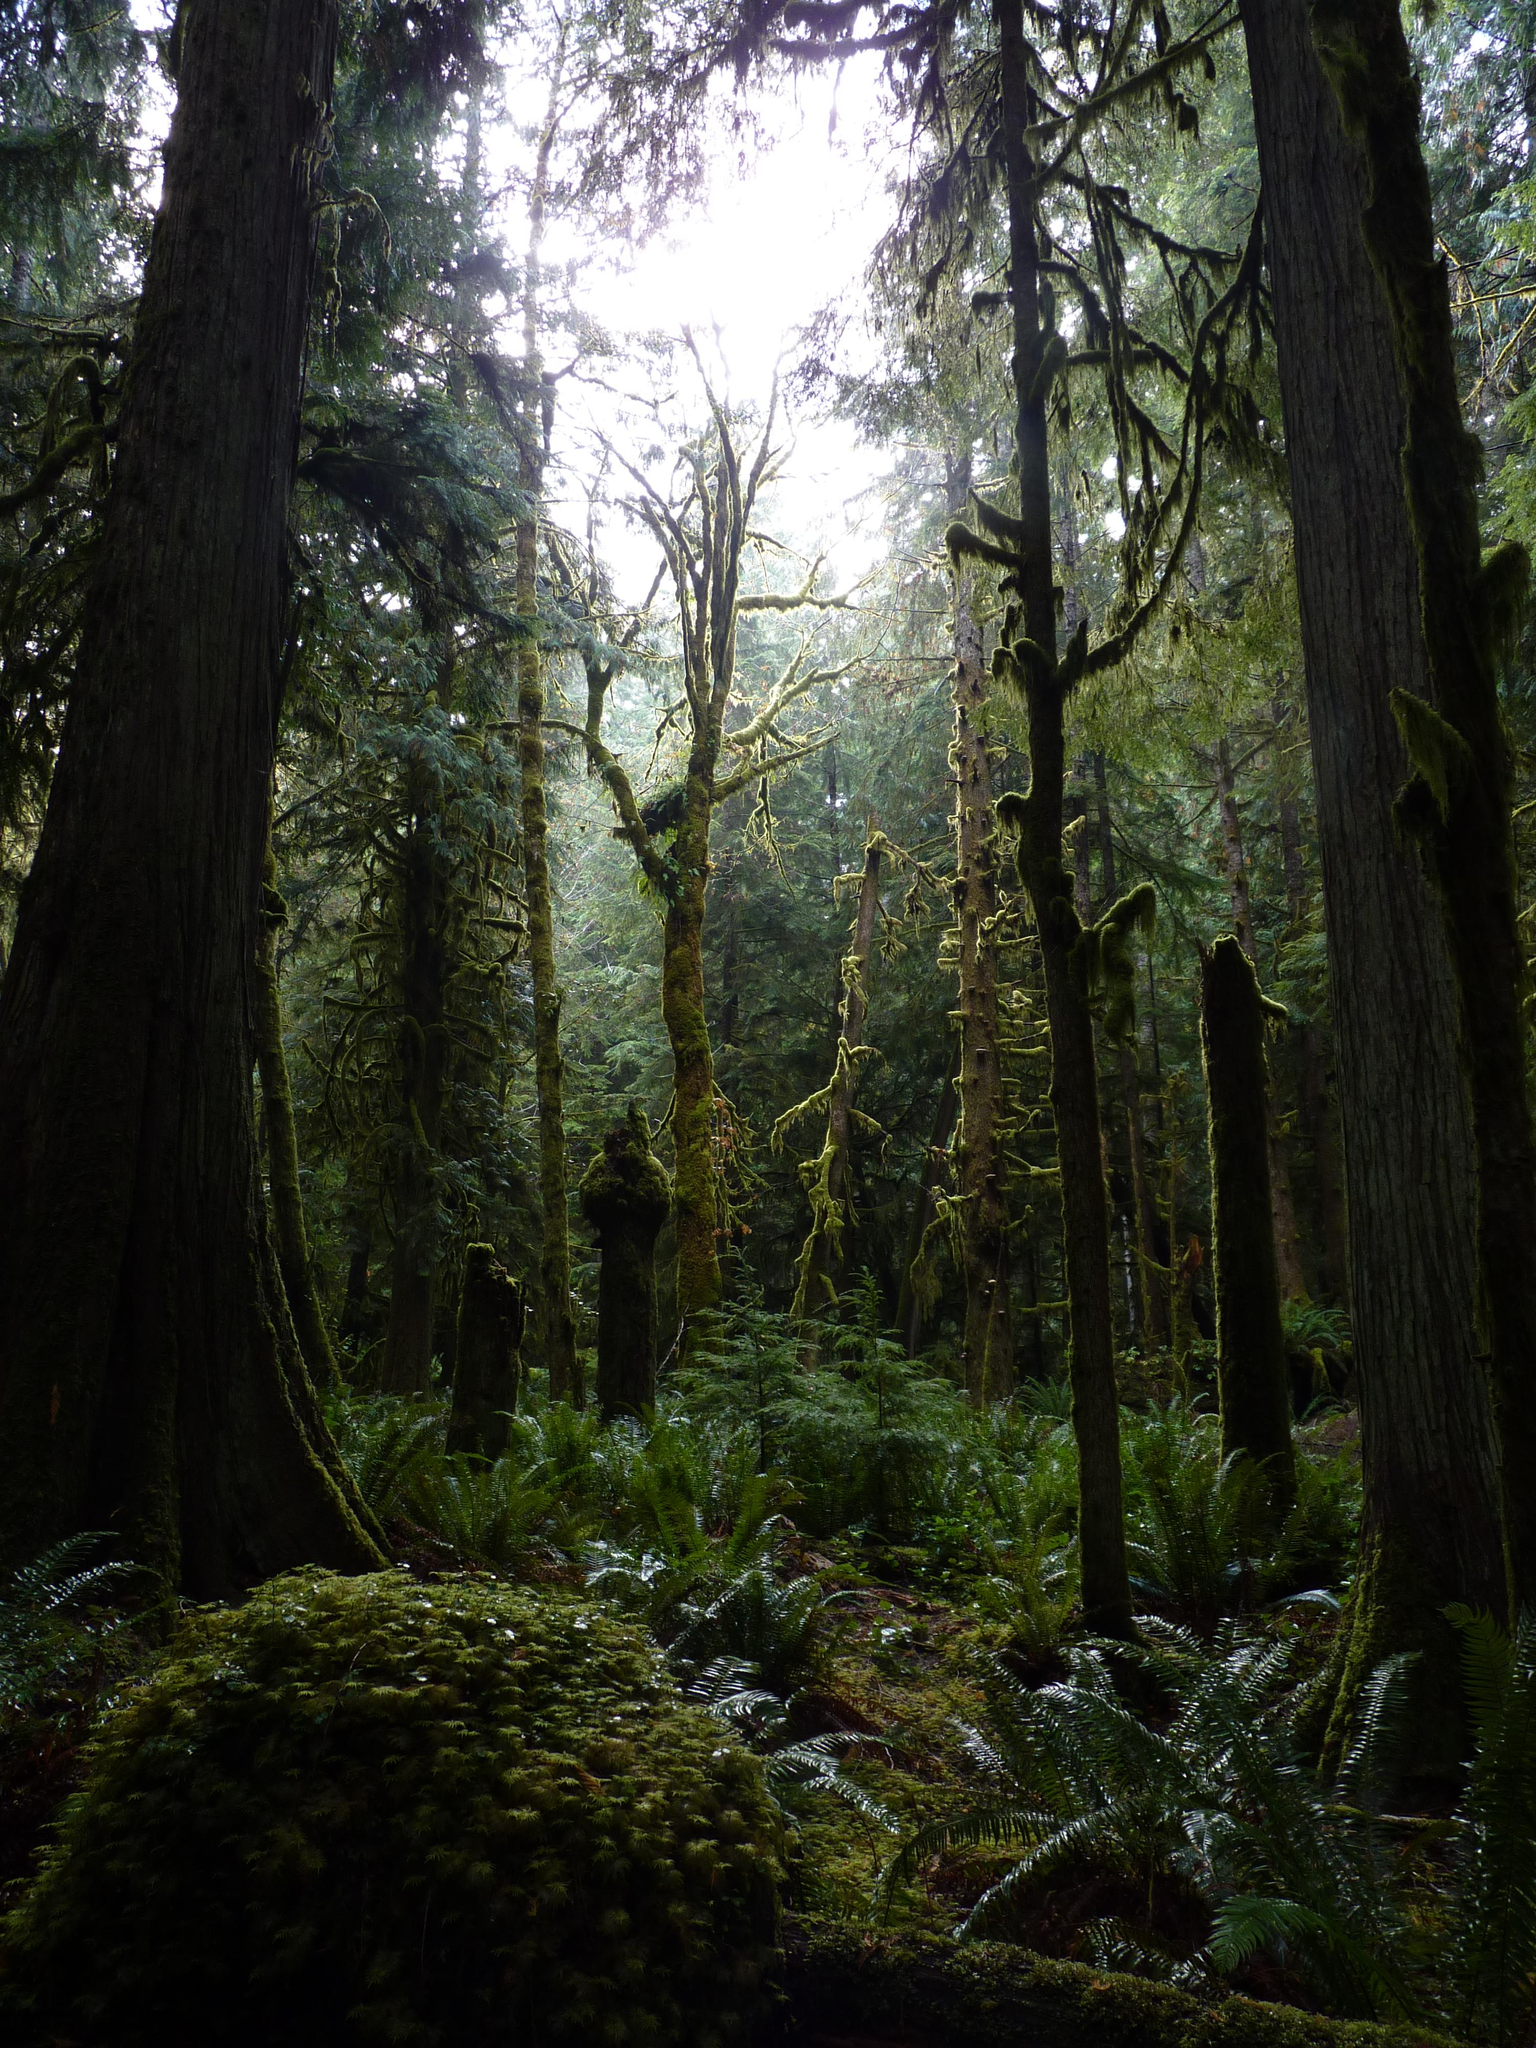What type of vegetation can be seen in the image? There are trees and plants in the image. What is visible at the ground level in the image? The ground is visible in the image. What part of the natural environment is visible in the background of the image? The sky is visible in the background of the image. What type of chain can be seen connecting the trees in the image? There is no chain present in the image; it features trees and plants without any visible connections between them. 